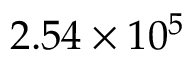Convert formula to latex. <formula><loc_0><loc_0><loc_500><loc_500>2 . 5 4 \times 1 0 ^ { 5 }</formula> 